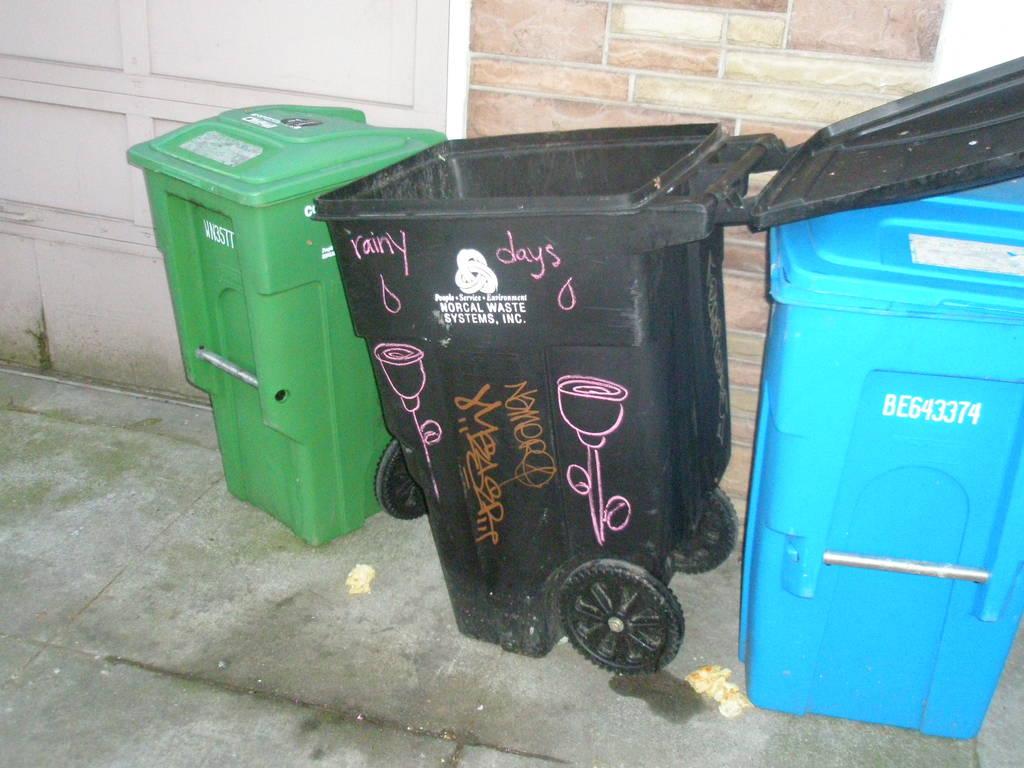What model number is on blue can?
Offer a terse response. Be643374. What kind of days?
Provide a short and direct response. Rainy. 